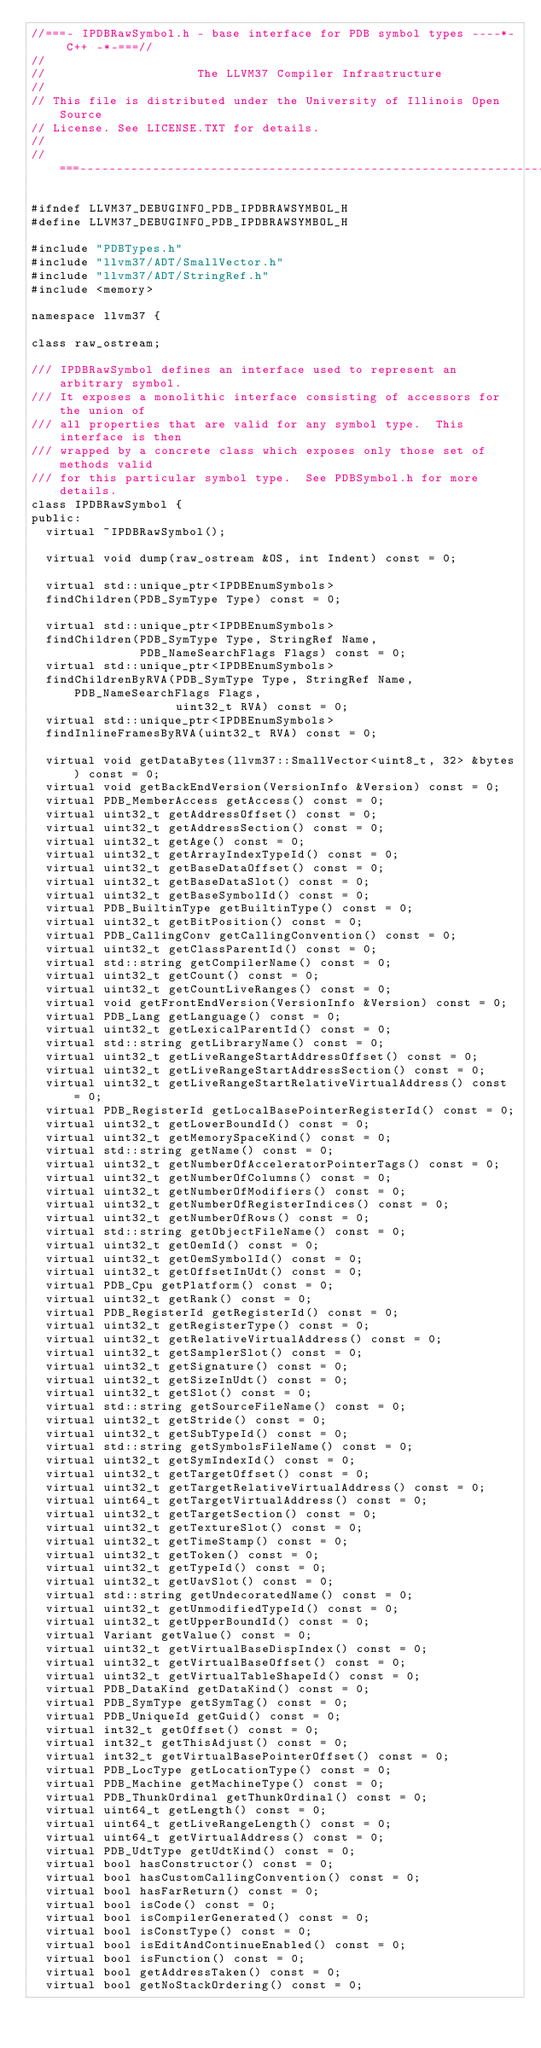Convert code to text. <code><loc_0><loc_0><loc_500><loc_500><_C_>//===- IPDBRawSymbol.h - base interface for PDB symbol types ----*- C++ -*-===//
//
//                     The LLVM37 Compiler Infrastructure
//
// This file is distributed under the University of Illinois Open Source
// License. See LICENSE.TXT for details.
//
//===----------------------------------------------------------------------===//

#ifndef LLVM37_DEBUGINFO_PDB_IPDBRAWSYMBOL_H
#define LLVM37_DEBUGINFO_PDB_IPDBRAWSYMBOL_H

#include "PDBTypes.h"
#include "llvm37/ADT/SmallVector.h"
#include "llvm37/ADT/StringRef.h"
#include <memory>

namespace llvm37 {

class raw_ostream;

/// IPDBRawSymbol defines an interface used to represent an arbitrary symbol.
/// It exposes a monolithic interface consisting of accessors for the union of
/// all properties that are valid for any symbol type.  This interface is then
/// wrapped by a concrete class which exposes only those set of methods valid
/// for this particular symbol type.  See PDBSymbol.h for more details.
class IPDBRawSymbol {
public:
  virtual ~IPDBRawSymbol();

  virtual void dump(raw_ostream &OS, int Indent) const = 0;

  virtual std::unique_ptr<IPDBEnumSymbols>
  findChildren(PDB_SymType Type) const = 0;

  virtual std::unique_ptr<IPDBEnumSymbols>
  findChildren(PDB_SymType Type, StringRef Name,
               PDB_NameSearchFlags Flags) const = 0;
  virtual std::unique_ptr<IPDBEnumSymbols>
  findChildrenByRVA(PDB_SymType Type, StringRef Name, PDB_NameSearchFlags Flags,
                    uint32_t RVA) const = 0;
  virtual std::unique_ptr<IPDBEnumSymbols>
  findInlineFramesByRVA(uint32_t RVA) const = 0;

  virtual void getDataBytes(llvm37::SmallVector<uint8_t, 32> &bytes) const = 0;
  virtual void getBackEndVersion(VersionInfo &Version) const = 0;
  virtual PDB_MemberAccess getAccess() const = 0;
  virtual uint32_t getAddressOffset() const = 0;
  virtual uint32_t getAddressSection() const = 0;
  virtual uint32_t getAge() const = 0;
  virtual uint32_t getArrayIndexTypeId() const = 0;
  virtual uint32_t getBaseDataOffset() const = 0;
  virtual uint32_t getBaseDataSlot() const = 0;
  virtual uint32_t getBaseSymbolId() const = 0;
  virtual PDB_BuiltinType getBuiltinType() const = 0;
  virtual uint32_t getBitPosition() const = 0;
  virtual PDB_CallingConv getCallingConvention() const = 0;
  virtual uint32_t getClassParentId() const = 0;
  virtual std::string getCompilerName() const = 0;
  virtual uint32_t getCount() const = 0;
  virtual uint32_t getCountLiveRanges() const = 0;
  virtual void getFrontEndVersion(VersionInfo &Version) const = 0;
  virtual PDB_Lang getLanguage() const = 0;
  virtual uint32_t getLexicalParentId() const = 0;
  virtual std::string getLibraryName() const = 0;
  virtual uint32_t getLiveRangeStartAddressOffset() const = 0;
  virtual uint32_t getLiveRangeStartAddressSection() const = 0;
  virtual uint32_t getLiveRangeStartRelativeVirtualAddress() const = 0;
  virtual PDB_RegisterId getLocalBasePointerRegisterId() const = 0;
  virtual uint32_t getLowerBoundId() const = 0;
  virtual uint32_t getMemorySpaceKind() const = 0;
  virtual std::string getName() const = 0;
  virtual uint32_t getNumberOfAcceleratorPointerTags() const = 0;
  virtual uint32_t getNumberOfColumns() const = 0;
  virtual uint32_t getNumberOfModifiers() const = 0;
  virtual uint32_t getNumberOfRegisterIndices() const = 0;
  virtual uint32_t getNumberOfRows() const = 0;
  virtual std::string getObjectFileName() const = 0;
  virtual uint32_t getOemId() const = 0;
  virtual uint32_t getOemSymbolId() const = 0;
  virtual uint32_t getOffsetInUdt() const = 0;
  virtual PDB_Cpu getPlatform() const = 0;
  virtual uint32_t getRank() const = 0;
  virtual PDB_RegisterId getRegisterId() const = 0;
  virtual uint32_t getRegisterType() const = 0;
  virtual uint32_t getRelativeVirtualAddress() const = 0;
  virtual uint32_t getSamplerSlot() const = 0;
  virtual uint32_t getSignature() const = 0;
  virtual uint32_t getSizeInUdt() const = 0;
  virtual uint32_t getSlot() const = 0;
  virtual std::string getSourceFileName() const = 0;
  virtual uint32_t getStride() const = 0;
  virtual uint32_t getSubTypeId() const = 0;
  virtual std::string getSymbolsFileName() const = 0;
  virtual uint32_t getSymIndexId() const = 0;
  virtual uint32_t getTargetOffset() const = 0;
  virtual uint32_t getTargetRelativeVirtualAddress() const = 0;
  virtual uint64_t getTargetVirtualAddress() const = 0;
  virtual uint32_t getTargetSection() const = 0;
  virtual uint32_t getTextureSlot() const = 0;
  virtual uint32_t getTimeStamp() const = 0;
  virtual uint32_t getToken() const = 0;
  virtual uint32_t getTypeId() const = 0;
  virtual uint32_t getUavSlot() const = 0;
  virtual std::string getUndecoratedName() const = 0;
  virtual uint32_t getUnmodifiedTypeId() const = 0;
  virtual uint32_t getUpperBoundId() const = 0;
  virtual Variant getValue() const = 0;
  virtual uint32_t getVirtualBaseDispIndex() const = 0;
  virtual uint32_t getVirtualBaseOffset() const = 0;
  virtual uint32_t getVirtualTableShapeId() const = 0;
  virtual PDB_DataKind getDataKind() const = 0;
  virtual PDB_SymType getSymTag() const = 0;
  virtual PDB_UniqueId getGuid() const = 0;
  virtual int32_t getOffset() const = 0;
  virtual int32_t getThisAdjust() const = 0;
  virtual int32_t getVirtualBasePointerOffset() const = 0;
  virtual PDB_LocType getLocationType() const = 0;
  virtual PDB_Machine getMachineType() const = 0;
  virtual PDB_ThunkOrdinal getThunkOrdinal() const = 0;
  virtual uint64_t getLength() const = 0;
  virtual uint64_t getLiveRangeLength() const = 0;
  virtual uint64_t getVirtualAddress() const = 0;
  virtual PDB_UdtType getUdtKind() const = 0;
  virtual bool hasConstructor() const = 0;
  virtual bool hasCustomCallingConvention() const = 0;
  virtual bool hasFarReturn() const = 0;
  virtual bool isCode() const = 0;
  virtual bool isCompilerGenerated() const = 0;
  virtual bool isConstType() const = 0;
  virtual bool isEditAndContinueEnabled() const = 0;
  virtual bool isFunction() const = 0;
  virtual bool getAddressTaken() const = 0;
  virtual bool getNoStackOrdering() const = 0;</code> 